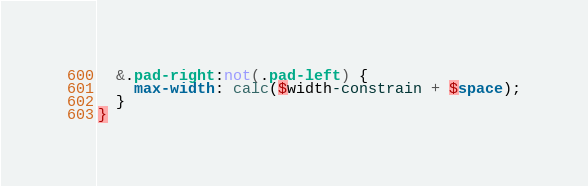Convert code to text. <code><loc_0><loc_0><loc_500><loc_500><_CSS_>  &.pad-right:not(.pad-left) {
    max-width: calc($width-constrain + $space);
  }
}</code> 